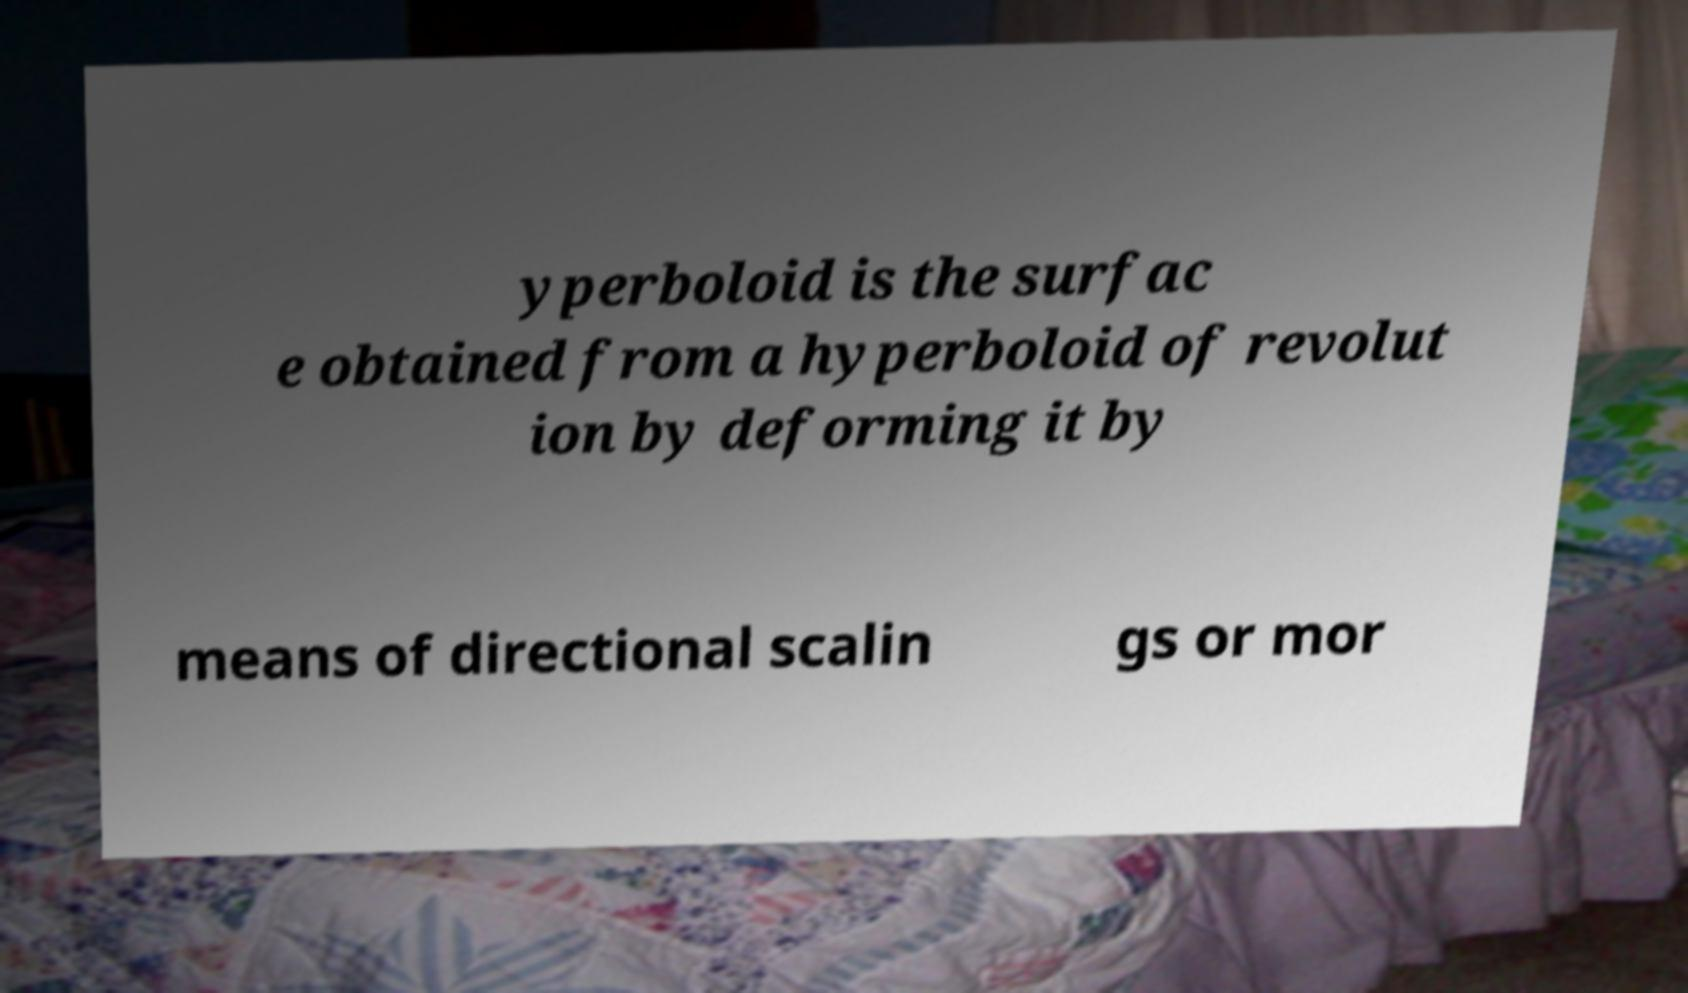Could you extract and type out the text from this image? yperboloid is the surfac e obtained from a hyperboloid of revolut ion by deforming it by means of directional scalin gs or mor 